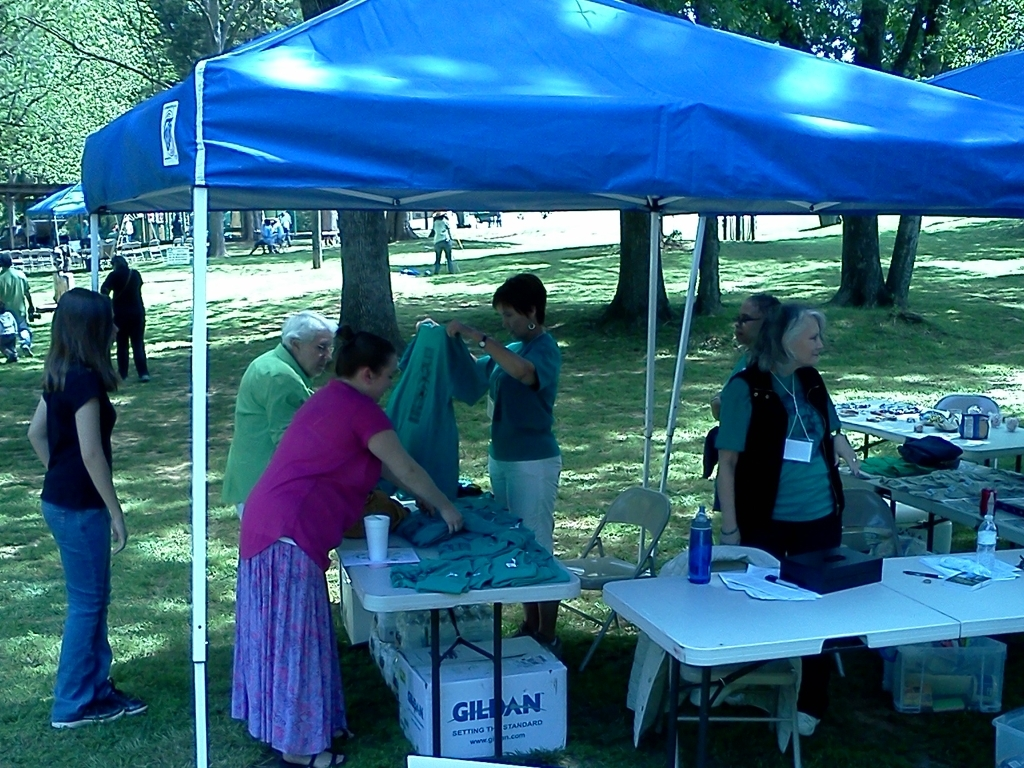Can you describe the event happening in this image? The image appears to capture an outdoor event, likely a community gathering or local fair, where multiple individuals are interacting under a blue canopy. There are tables set up with various items on display, suggesting it could be an information booth or a registration area for the event. What could all those items on the table be for? The items on the table could serve a variety of purposes, such as informational brochures, sign-up sheets, promotional goods like pens or stickers, or even light refreshments for the attendees. Such materials are common in events that aim to engage with the community or raise awareness about a specific cause or organization. 